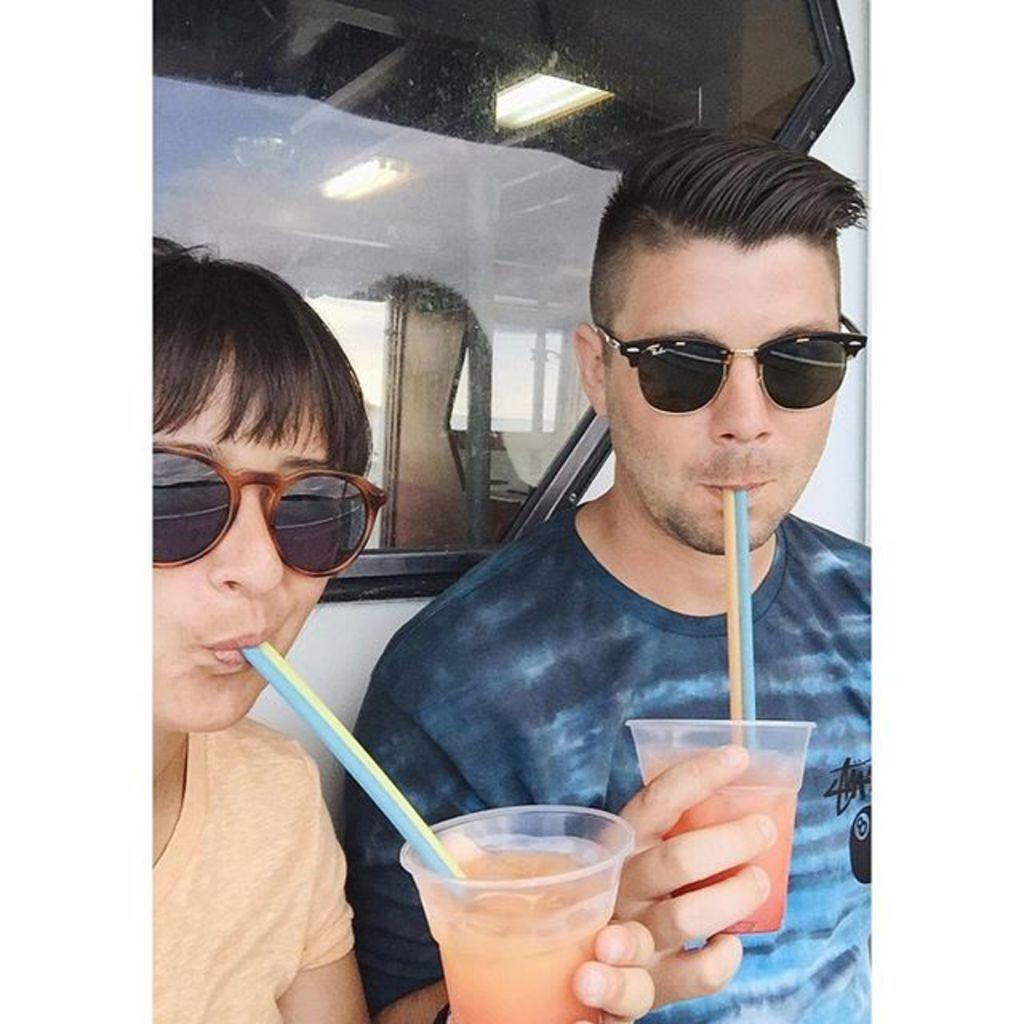How many people are in the image? There are two persons in the image. What are the persons wearing? The persons are wearing goggles. What are the persons holding in the image? The persons are holding a glass of juice. What are the persons doing with the juice? The persons are drinking the juice. Can you describe the object behind the two persons? There is a glass behind the two persons. What type of finger painting can be seen on the wall behind the persons? There is no finger painting present in the image; the persons are wearing goggles and holding glasses of juice. 